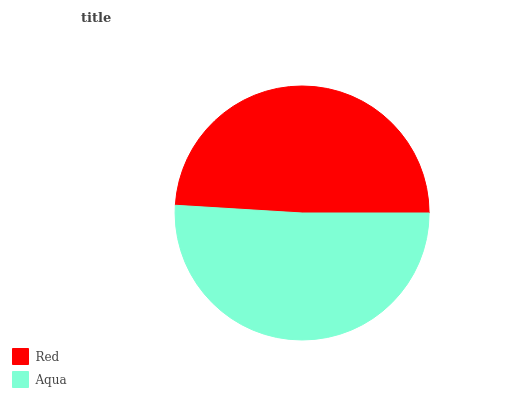Is Red the minimum?
Answer yes or no. Yes. Is Aqua the maximum?
Answer yes or no. Yes. Is Aqua the minimum?
Answer yes or no. No. Is Aqua greater than Red?
Answer yes or no. Yes. Is Red less than Aqua?
Answer yes or no. Yes. Is Red greater than Aqua?
Answer yes or no. No. Is Aqua less than Red?
Answer yes or no. No. Is Aqua the high median?
Answer yes or no. Yes. Is Red the low median?
Answer yes or no. Yes. Is Red the high median?
Answer yes or no. No. Is Aqua the low median?
Answer yes or no. No. 